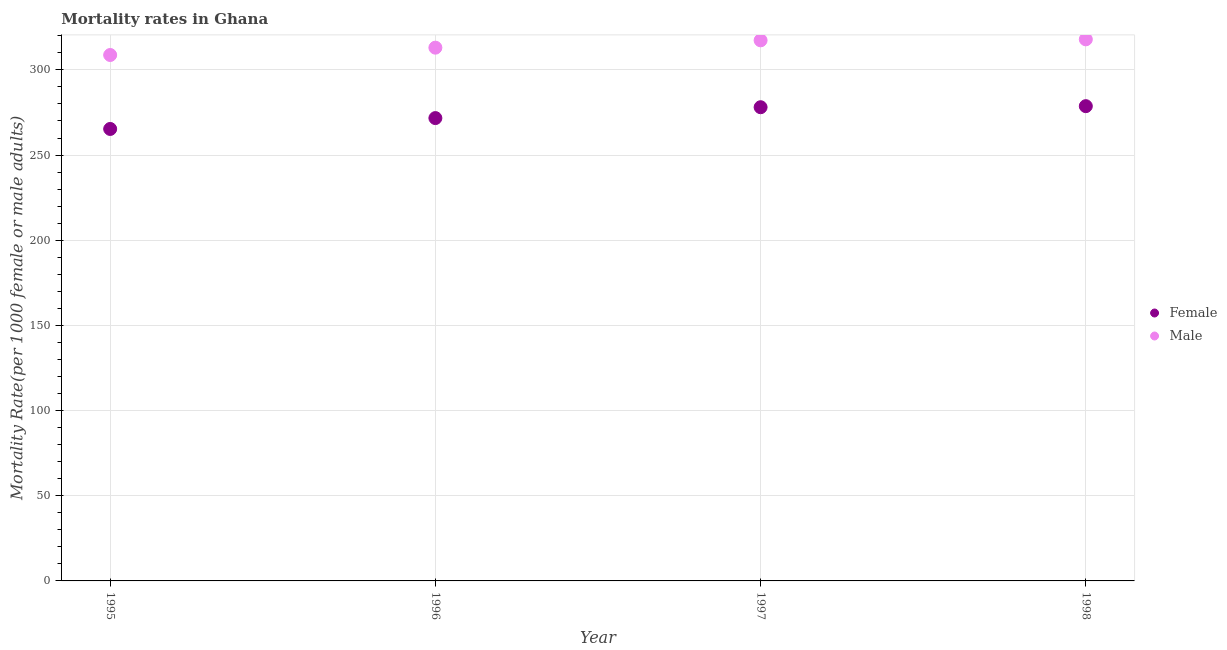How many different coloured dotlines are there?
Your answer should be very brief. 2. What is the female mortality rate in 1998?
Make the answer very short. 278.69. Across all years, what is the maximum male mortality rate?
Offer a terse response. 317.91. Across all years, what is the minimum male mortality rate?
Offer a terse response. 308.73. In which year was the male mortality rate minimum?
Provide a short and direct response. 1995. What is the total male mortality rate in the graph?
Make the answer very short. 1257. What is the difference between the female mortality rate in 1997 and that in 1998?
Give a very brief answer. -0.62. What is the difference between the male mortality rate in 1996 and the female mortality rate in 1998?
Your answer should be compact. 34.33. What is the average female mortality rate per year?
Your answer should be very brief. 273.44. In the year 1995, what is the difference between the female mortality rate and male mortality rate?
Make the answer very short. -43.41. In how many years, is the female mortality rate greater than 60?
Offer a very short reply. 4. What is the ratio of the male mortality rate in 1995 to that in 1996?
Make the answer very short. 0.99. Is the female mortality rate in 1995 less than that in 1998?
Provide a short and direct response. Yes. Is the difference between the male mortality rate in 1995 and 1998 greater than the difference between the female mortality rate in 1995 and 1998?
Give a very brief answer. Yes. What is the difference between the highest and the second highest female mortality rate?
Provide a short and direct response. 0.62. What is the difference between the highest and the lowest female mortality rate?
Your answer should be very brief. 13.38. Is the sum of the female mortality rate in 1996 and 1998 greater than the maximum male mortality rate across all years?
Make the answer very short. Yes. Is the female mortality rate strictly less than the male mortality rate over the years?
Give a very brief answer. Yes. Are the values on the major ticks of Y-axis written in scientific E-notation?
Make the answer very short. No. Does the graph contain grids?
Give a very brief answer. Yes. Where does the legend appear in the graph?
Ensure brevity in your answer.  Center right. How many legend labels are there?
Offer a terse response. 2. What is the title of the graph?
Give a very brief answer. Mortality rates in Ghana. What is the label or title of the X-axis?
Keep it short and to the point. Year. What is the label or title of the Y-axis?
Offer a terse response. Mortality Rate(per 1000 female or male adults). What is the Mortality Rate(per 1000 female or male adults) in Female in 1995?
Offer a very short reply. 265.31. What is the Mortality Rate(per 1000 female or male adults) of Male in 1995?
Provide a succinct answer. 308.73. What is the Mortality Rate(per 1000 female or male adults) of Female in 1996?
Your answer should be compact. 271.69. What is the Mortality Rate(per 1000 female or male adults) in Male in 1996?
Provide a succinct answer. 313.03. What is the Mortality Rate(per 1000 female or male adults) of Female in 1997?
Ensure brevity in your answer.  278.07. What is the Mortality Rate(per 1000 female or male adults) in Male in 1997?
Offer a very short reply. 317.33. What is the Mortality Rate(per 1000 female or male adults) in Female in 1998?
Your answer should be compact. 278.69. What is the Mortality Rate(per 1000 female or male adults) in Male in 1998?
Ensure brevity in your answer.  317.91. Across all years, what is the maximum Mortality Rate(per 1000 female or male adults) in Female?
Offer a very short reply. 278.69. Across all years, what is the maximum Mortality Rate(per 1000 female or male adults) in Male?
Your response must be concise. 317.91. Across all years, what is the minimum Mortality Rate(per 1000 female or male adults) of Female?
Offer a very short reply. 265.31. Across all years, what is the minimum Mortality Rate(per 1000 female or male adults) of Male?
Give a very brief answer. 308.73. What is the total Mortality Rate(per 1000 female or male adults) of Female in the graph?
Offer a very short reply. 1093.77. What is the total Mortality Rate(per 1000 female or male adults) of Male in the graph?
Provide a succinct answer. 1257. What is the difference between the Mortality Rate(per 1000 female or male adults) of Female in 1995 and that in 1996?
Make the answer very short. -6.38. What is the difference between the Mortality Rate(per 1000 female or male adults) in Male in 1995 and that in 1996?
Your response must be concise. -4.3. What is the difference between the Mortality Rate(per 1000 female or male adults) of Female in 1995 and that in 1997?
Offer a terse response. -12.76. What is the difference between the Mortality Rate(per 1000 female or male adults) in Male in 1995 and that in 1997?
Provide a succinct answer. -8.61. What is the difference between the Mortality Rate(per 1000 female or male adults) in Female in 1995 and that in 1998?
Give a very brief answer. -13.38. What is the difference between the Mortality Rate(per 1000 female or male adults) in Male in 1995 and that in 1998?
Your response must be concise. -9.19. What is the difference between the Mortality Rate(per 1000 female or male adults) in Female in 1996 and that in 1997?
Give a very brief answer. -6.38. What is the difference between the Mortality Rate(per 1000 female or male adults) in Male in 1996 and that in 1997?
Make the answer very short. -4.3. What is the difference between the Mortality Rate(per 1000 female or male adults) of Female in 1996 and that in 1998?
Provide a short and direct response. -7. What is the difference between the Mortality Rate(per 1000 female or male adults) of Male in 1996 and that in 1998?
Keep it short and to the point. -4.88. What is the difference between the Mortality Rate(per 1000 female or male adults) in Female in 1997 and that in 1998?
Provide a succinct answer. -0.62. What is the difference between the Mortality Rate(per 1000 female or male adults) of Male in 1997 and that in 1998?
Your answer should be compact. -0.58. What is the difference between the Mortality Rate(per 1000 female or male adults) of Female in 1995 and the Mortality Rate(per 1000 female or male adults) of Male in 1996?
Your response must be concise. -47.72. What is the difference between the Mortality Rate(per 1000 female or male adults) of Female in 1995 and the Mortality Rate(per 1000 female or male adults) of Male in 1997?
Ensure brevity in your answer.  -52.02. What is the difference between the Mortality Rate(per 1000 female or male adults) of Female in 1995 and the Mortality Rate(per 1000 female or male adults) of Male in 1998?
Your answer should be very brief. -52.6. What is the difference between the Mortality Rate(per 1000 female or male adults) of Female in 1996 and the Mortality Rate(per 1000 female or male adults) of Male in 1997?
Give a very brief answer. -45.64. What is the difference between the Mortality Rate(per 1000 female or male adults) of Female in 1996 and the Mortality Rate(per 1000 female or male adults) of Male in 1998?
Your answer should be very brief. -46.22. What is the difference between the Mortality Rate(per 1000 female or male adults) of Female in 1997 and the Mortality Rate(per 1000 female or male adults) of Male in 1998?
Provide a succinct answer. -39.84. What is the average Mortality Rate(per 1000 female or male adults) of Female per year?
Your answer should be compact. 273.44. What is the average Mortality Rate(per 1000 female or male adults) of Male per year?
Give a very brief answer. 314.25. In the year 1995, what is the difference between the Mortality Rate(per 1000 female or male adults) of Female and Mortality Rate(per 1000 female or male adults) of Male?
Ensure brevity in your answer.  -43.41. In the year 1996, what is the difference between the Mortality Rate(per 1000 female or male adults) of Female and Mortality Rate(per 1000 female or male adults) of Male?
Your answer should be compact. -41.34. In the year 1997, what is the difference between the Mortality Rate(per 1000 female or male adults) of Female and Mortality Rate(per 1000 female or male adults) of Male?
Your response must be concise. -39.26. In the year 1998, what is the difference between the Mortality Rate(per 1000 female or male adults) of Female and Mortality Rate(per 1000 female or male adults) of Male?
Provide a short and direct response. -39.22. What is the ratio of the Mortality Rate(per 1000 female or male adults) in Female in 1995 to that in 1996?
Your answer should be very brief. 0.98. What is the ratio of the Mortality Rate(per 1000 female or male adults) in Male in 1995 to that in 1996?
Ensure brevity in your answer.  0.99. What is the ratio of the Mortality Rate(per 1000 female or male adults) of Female in 1995 to that in 1997?
Provide a succinct answer. 0.95. What is the ratio of the Mortality Rate(per 1000 female or male adults) in Male in 1995 to that in 1997?
Offer a terse response. 0.97. What is the ratio of the Mortality Rate(per 1000 female or male adults) of Male in 1995 to that in 1998?
Offer a very short reply. 0.97. What is the ratio of the Mortality Rate(per 1000 female or male adults) in Female in 1996 to that in 1997?
Ensure brevity in your answer.  0.98. What is the ratio of the Mortality Rate(per 1000 female or male adults) in Male in 1996 to that in 1997?
Your response must be concise. 0.99. What is the ratio of the Mortality Rate(per 1000 female or male adults) of Female in 1996 to that in 1998?
Ensure brevity in your answer.  0.97. What is the ratio of the Mortality Rate(per 1000 female or male adults) in Male in 1996 to that in 1998?
Give a very brief answer. 0.98. What is the ratio of the Mortality Rate(per 1000 female or male adults) of Female in 1997 to that in 1998?
Your answer should be compact. 1. What is the ratio of the Mortality Rate(per 1000 female or male adults) in Male in 1997 to that in 1998?
Make the answer very short. 1. What is the difference between the highest and the second highest Mortality Rate(per 1000 female or male adults) of Female?
Your answer should be very brief. 0.62. What is the difference between the highest and the second highest Mortality Rate(per 1000 female or male adults) of Male?
Your response must be concise. 0.58. What is the difference between the highest and the lowest Mortality Rate(per 1000 female or male adults) of Female?
Provide a short and direct response. 13.38. What is the difference between the highest and the lowest Mortality Rate(per 1000 female or male adults) of Male?
Ensure brevity in your answer.  9.19. 